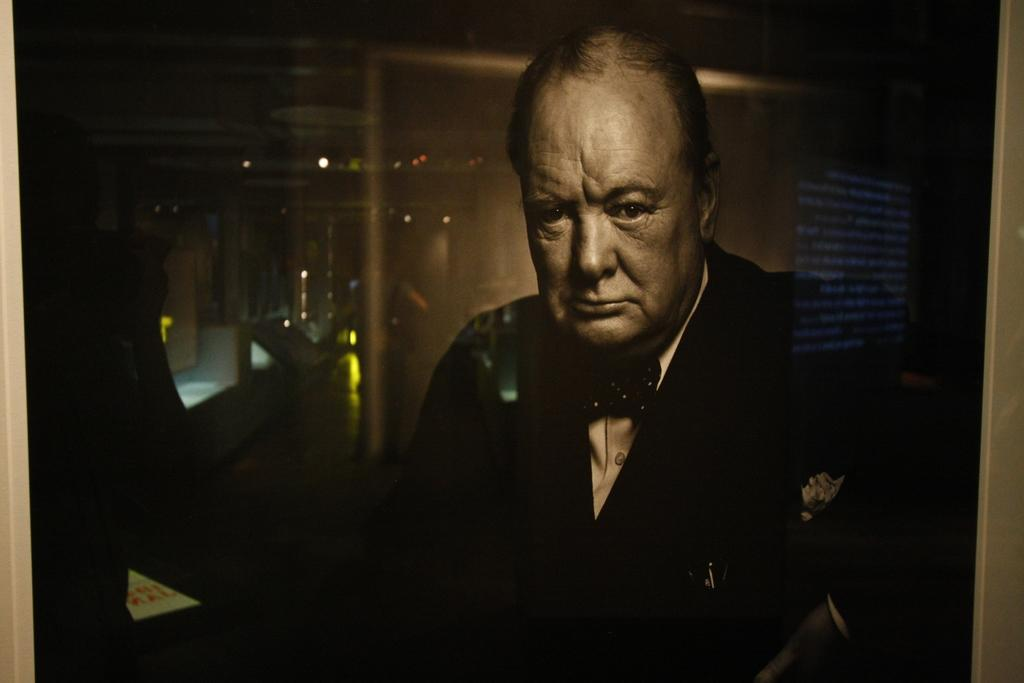What is present in the image? There is a man and a table in the image. Can you describe the lighting in the image? The image is dark. What type of cap is the man wearing in the image? There is no cap visible in the image. What is the name of the man in the image? The name of the man cannot be determined from the image. 